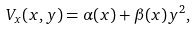Convert formula to latex. <formula><loc_0><loc_0><loc_500><loc_500>V _ { x } ( x , y ) = \alpha ( x ) + \beta ( x ) y ^ { 2 } ,</formula> 